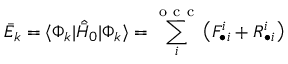Convert formula to latex. <formula><loc_0><loc_0><loc_500><loc_500>\bar { E } _ { k } = \langle \Phi _ { k } | \hat { \bar { H } } _ { 0 } | \Phi _ { k } \rangle = \sum _ { i } ^ { o c c } \left ( F _ { \bullet i } ^ { i } + R _ { \bullet i } ^ { i } \right )</formula> 